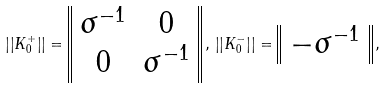Convert formula to latex. <formula><loc_0><loc_0><loc_500><loc_500>\left | \left | K ^ { + } _ { 0 } \right | \right | = \begin{array} { | | c c | | } \sigma ^ { - 1 } & 0 \\ 0 & \sigma ^ { - 1 } \end{array} \, , \, \left | \left | K ^ { - } _ { 0 } \right | \right | = \begin{array} { | | c | | } - \sigma ^ { - 1 } \end{array} \, ,</formula> 